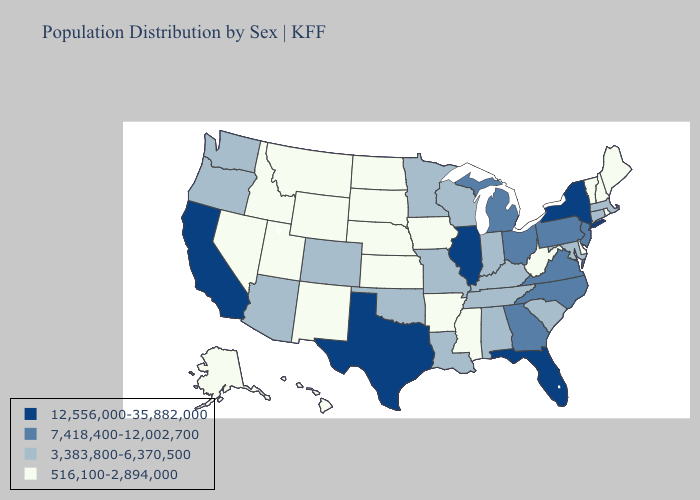Which states have the lowest value in the USA?
Concise answer only. Alaska, Arkansas, Delaware, Hawaii, Idaho, Iowa, Kansas, Maine, Mississippi, Montana, Nebraska, Nevada, New Hampshire, New Mexico, North Dakota, Rhode Island, South Dakota, Utah, Vermont, West Virginia, Wyoming. What is the lowest value in states that border Minnesota?
Answer briefly. 516,100-2,894,000. What is the lowest value in the Northeast?
Concise answer only. 516,100-2,894,000. What is the lowest value in the West?
Quick response, please. 516,100-2,894,000. Does Vermont have the highest value in the Northeast?
Short answer required. No. What is the highest value in the USA?
Quick response, please. 12,556,000-35,882,000. Is the legend a continuous bar?
Short answer required. No. Which states hav the highest value in the MidWest?
Write a very short answer. Illinois. Among the states that border New Hampshire , which have the highest value?
Concise answer only. Massachusetts. Name the states that have a value in the range 12,556,000-35,882,000?
Give a very brief answer. California, Florida, Illinois, New York, Texas. What is the value of South Carolina?
Quick response, please. 3,383,800-6,370,500. Name the states that have a value in the range 3,383,800-6,370,500?
Quick response, please. Alabama, Arizona, Colorado, Connecticut, Indiana, Kentucky, Louisiana, Maryland, Massachusetts, Minnesota, Missouri, Oklahoma, Oregon, South Carolina, Tennessee, Washington, Wisconsin. What is the value of Vermont?
Give a very brief answer. 516,100-2,894,000. Name the states that have a value in the range 12,556,000-35,882,000?
Answer briefly. California, Florida, Illinois, New York, Texas. Among the states that border Wisconsin , does Illinois have the highest value?
Concise answer only. Yes. 